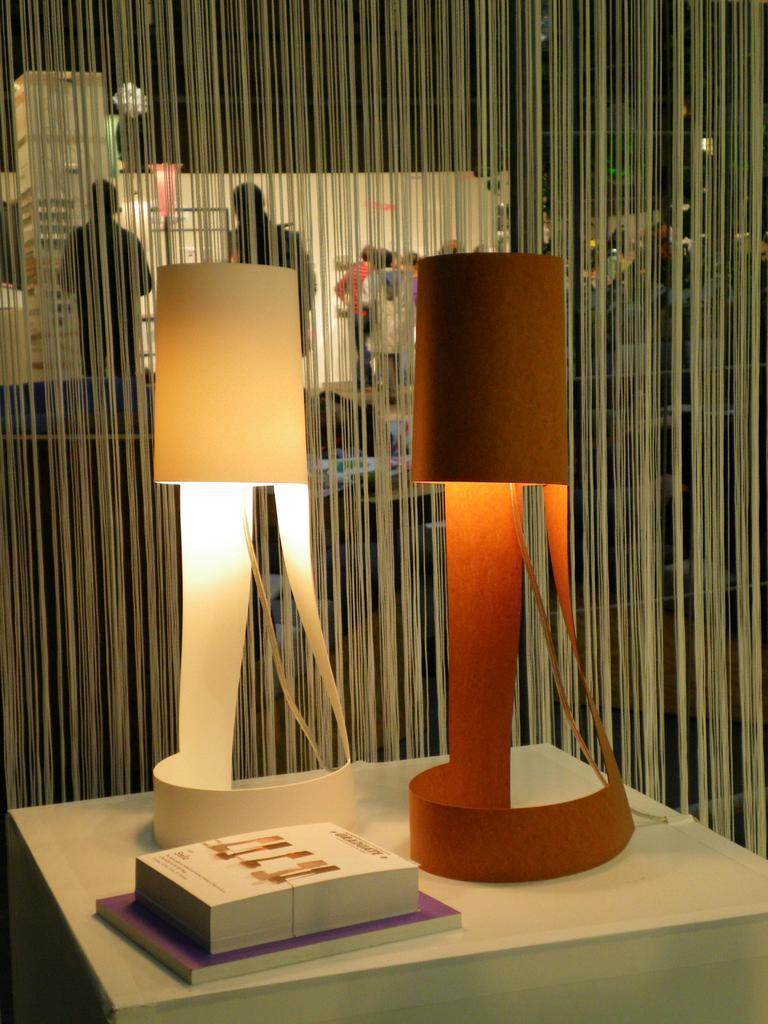What is the main structure in the image? There is a platform in the image. What items can be seen on the platform? There are books and table lamps on the platform. What is visible in the background of the image? There is a curtain and many people in the background of the image. What type of liquid can be seen flowing from the books in the image? There is no liquid flowing from the books in the image; they are stationary on the platform. 